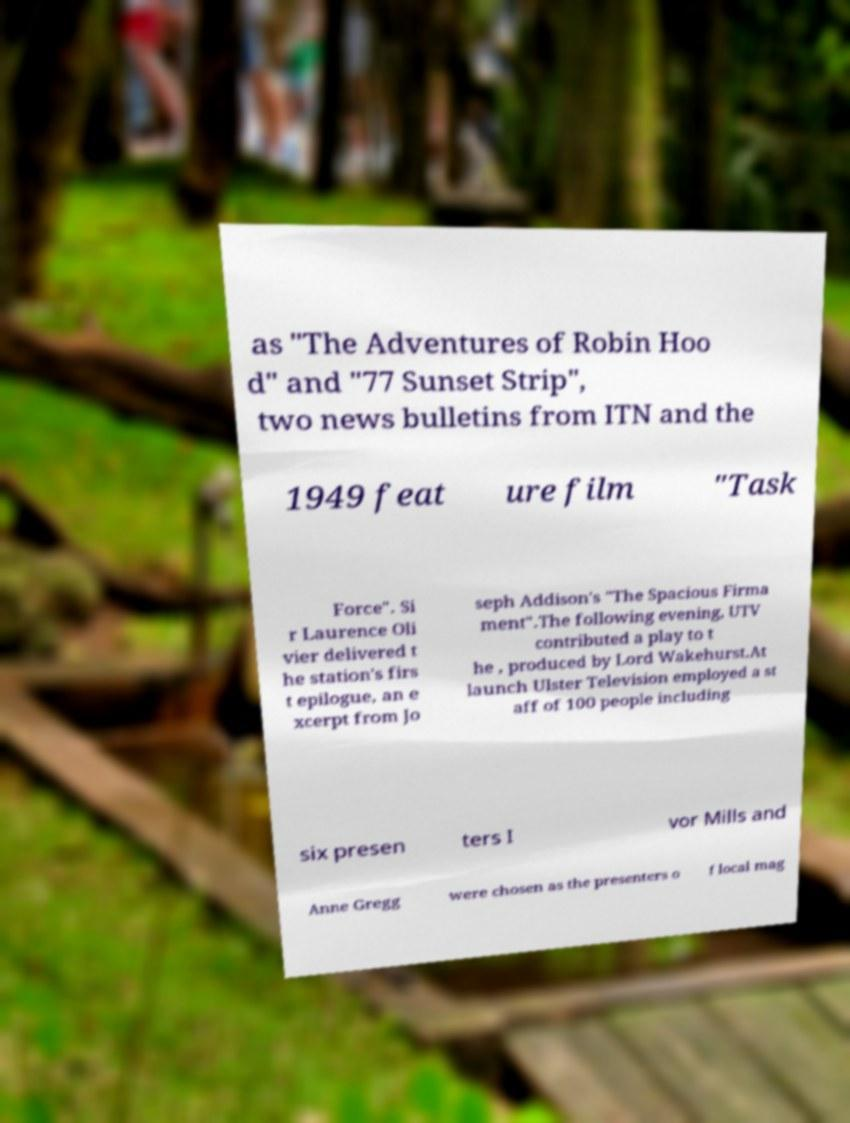There's text embedded in this image that I need extracted. Can you transcribe it verbatim? as "The Adventures of Robin Hoo d" and "77 Sunset Strip", two news bulletins from ITN and the 1949 feat ure film "Task Force". Si r Laurence Oli vier delivered t he station's firs t epilogue, an e xcerpt from Jo seph Addison's "The Spacious Firma ment".The following evening, UTV contributed a play to t he , produced by Lord Wakehurst.At launch Ulster Television employed a st aff of 100 people including six presen ters I vor Mills and Anne Gregg were chosen as the presenters o f local mag 